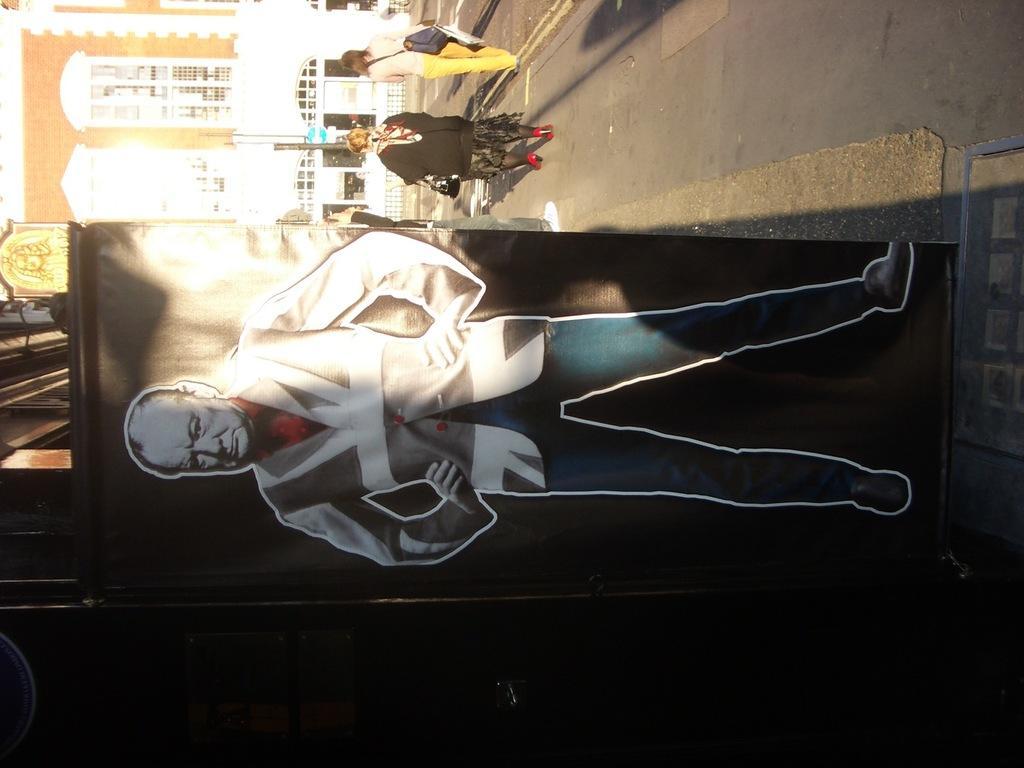Could you give a brief overview of what you see in this image? In this image we can see a board with an image of a person. Also there is a road. On the road there are few people. Also there are buildings. And persons are having bags. 